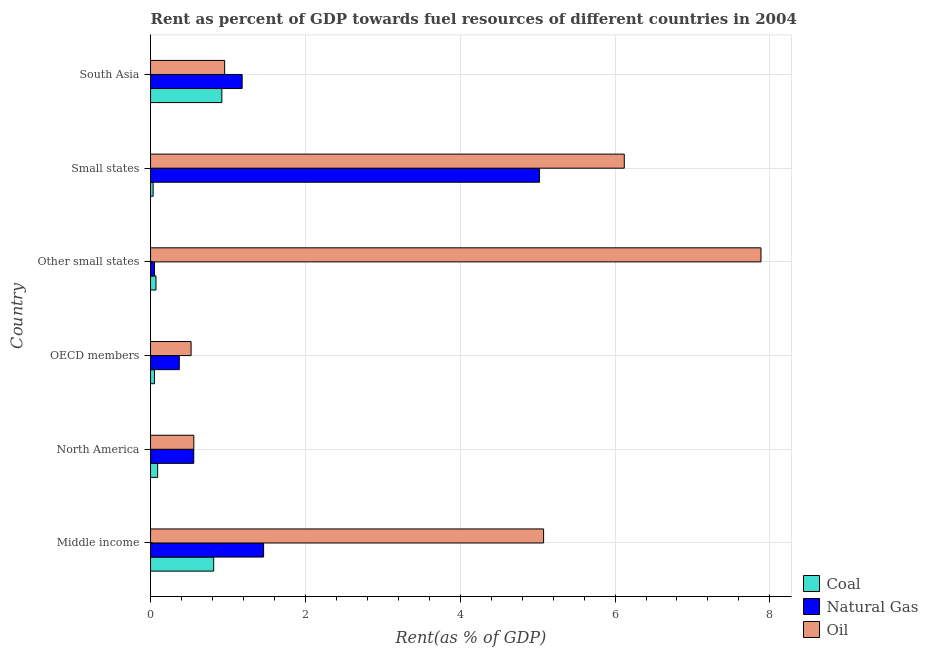How many bars are there on the 6th tick from the bottom?
Offer a very short reply. 3. What is the rent towards oil in Other small states?
Provide a succinct answer. 7.89. Across all countries, what is the maximum rent towards oil?
Offer a terse response. 7.89. Across all countries, what is the minimum rent towards coal?
Give a very brief answer. 0.03. In which country was the rent towards natural gas maximum?
Your answer should be very brief. Small states. In which country was the rent towards coal minimum?
Your response must be concise. Small states. What is the total rent towards oil in the graph?
Offer a terse response. 21.12. What is the difference between the rent towards oil in Small states and that in South Asia?
Keep it short and to the point. 5.16. What is the difference between the rent towards natural gas in South Asia and the rent towards coal in Small states?
Provide a succinct answer. 1.15. What is the average rent towards oil per country?
Provide a short and direct response. 3.52. What is the difference between the rent towards coal and rent towards natural gas in North America?
Ensure brevity in your answer.  -0.47. What is the ratio of the rent towards natural gas in Middle income to that in South Asia?
Ensure brevity in your answer.  1.23. Is the rent towards oil in Middle income less than that in North America?
Keep it short and to the point. No. What is the difference between the highest and the second highest rent towards oil?
Provide a short and direct response. 1.77. What is the difference between the highest and the lowest rent towards natural gas?
Offer a very short reply. 4.97. What does the 1st bar from the top in South Asia represents?
Provide a short and direct response. Oil. What does the 3rd bar from the bottom in Other small states represents?
Your response must be concise. Oil. Is it the case that in every country, the sum of the rent towards coal and rent towards natural gas is greater than the rent towards oil?
Give a very brief answer. No. What is the difference between two consecutive major ticks on the X-axis?
Your response must be concise. 2. Are the values on the major ticks of X-axis written in scientific E-notation?
Your answer should be very brief. No. Does the graph contain any zero values?
Make the answer very short. No. Does the graph contain grids?
Offer a terse response. Yes. Where does the legend appear in the graph?
Your answer should be compact. Bottom right. How many legend labels are there?
Your answer should be very brief. 3. What is the title of the graph?
Provide a short and direct response. Rent as percent of GDP towards fuel resources of different countries in 2004. Does "Industry" appear as one of the legend labels in the graph?
Your response must be concise. No. What is the label or title of the X-axis?
Give a very brief answer. Rent(as % of GDP). What is the Rent(as % of GDP) of Coal in Middle income?
Provide a short and direct response. 0.82. What is the Rent(as % of GDP) of Natural Gas in Middle income?
Keep it short and to the point. 1.46. What is the Rent(as % of GDP) in Oil in Middle income?
Provide a short and direct response. 5.08. What is the Rent(as % of GDP) in Coal in North America?
Your response must be concise. 0.09. What is the Rent(as % of GDP) of Natural Gas in North America?
Ensure brevity in your answer.  0.56. What is the Rent(as % of GDP) of Oil in North America?
Your answer should be compact. 0.56. What is the Rent(as % of GDP) in Coal in OECD members?
Keep it short and to the point. 0.05. What is the Rent(as % of GDP) of Natural Gas in OECD members?
Offer a terse response. 0.37. What is the Rent(as % of GDP) of Oil in OECD members?
Make the answer very short. 0.52. What is the Rent(as % of GDP) of Coal in Other small states?
Make the answer very short. 0.07. What is the Rent(as % of GDP) of Natural Gas in Other small states?
Offer a terse response. 0.05. What is the Rent(as % of GDP) in Oil in Other small states?
Give a very brief answer. 7.89. What is the Rent(as % of GDP) in Coal in Small states?
Ensure brevity in your answer.  0.03. What is the Rent(as % of GDP) of Natural Gas in Small states?
Provide a short and direct response. 5.02. What is the Rent(as % of GDP) in Oil in Small states?
Ensure brevity in your answer.  6.12. What is the Rent(as % of GDP) of Coal in South Asia?
Your answer should be very brief. 0.92. What is the Rent(as % of GDP) in Natural Gas in South Asia?
Provide a succinct answer. 1.18. What is the Rent(as % of GDP) in Oil in South Asia?
Ensure brevity in your answer.  0.96. Across all countries, what is the maximum Rent(as % of GDP) in Coal?
Provide a succinct answer. 0.92. Across all countries, what is the maximum Rent(as % of GDP) of Natural Gas?
Offer a very short reply. 5.02. Across all countries, what is the maximum Rent(as % of GDP) in Oil?
Your answer should be very brief. 7.89. Across all countries, what is the minimum Rent(as % of GDP) of Coal?
Your response must be concise. 0.03. Across all countries, what is the minimum Rent(as % of GDP) in Natural Gas?
Provide a succinct answer. 0.05. Across all countries, what is the minimum Rent(as % of GDP) in Oil?
Keep it short and to the point. 0.52. What is the total Rent(as % of GDP) in Coal in the graph?
Offer a terse response. 1.98. What is the total Rent(as % of GDP) of Natural Gas in the graph?
Offer a very short reply. 8.65. What is the total Rent(as % of GDP) of Oil in the graph?
Offer a terse response. 21.12. What is the difference between the Rent(as % of GDP) of Coal in Middle income and that in North America?
Keep it short and to the point. 0.72. What is the difference between the Rent(as % of GDP) in Natural Gas in Middle income and that in North America?
Keep it short and to the point. 0.9. What is the difference between the Rent(as % of GDP) in Oil in Middle income and that in North America?
Keep it short and to the point. 4.52. What is the difference between the Rent(as % of GDP) in Coal in Middle income and that in OECD members?
Your answer should be compact. 0.77. What is the difference between the Rent(as % of GDP) in Natural Gas in Middle income and that in OECD members?
Your answer should be very brief. 1.09. What is the difference between the Rent(as % of GDP) of Oil in Middle income and that in OECD members?
Make the answer very short. 4.55. What is the difference between the Rent(as % of GDP) of Coal in Middle income and that in Other small states?
Make the answer very short. 0.75. What is the difference between the Rent(as % of GDP) in Natural Gas in Middle income and that in Other small states?
Offer a very short reply. 1.41. What is the difference between the Rent(as % of GDP) in Oil in Middle income and that in Other small states?
Your answer should be very brief. -2.81. What is the difference between the Rent(as % of GDP) in Coal in Middle income and that in Small states?
Provide a succinct answer. 0.78. What is the difference between the Rent(as % of GDP) in Natural Gas in Middle income and that in Small states?
Give a very brief answer. -3.56. What is the difference between the Rent(as % of GDP) of Oil in Middle income and that in Small states?
Provide a short and direct response. -1.04. What is the difference between the Rent(as % of GDP) of Coal in Middle income and that in South Asia?
Offer a terse response. -0.1. What is the difference between the Rent(as % of GDP) of Natural Gas in Middle income and that in South Asia?
Your response must be concise. 0.28. What is the difference between the Rent(as % of GDP) in Oil in Middle income and that in South Asia?
Provide a succinct answer. 4.12. What is the difference between the Rent(as % of GDP) of Coal in North America and that in OECD members?
Your answer should be compact. 0.04. What is the difference between the Rent(as % of GDP) of Natural Gas in North America and that in OECD members?
Provide a short and direct response. 0.19. What is the difference between the Rent(as % of GDP) in Oil in North America and that in OECD members?
Your answer should be very brief. 0.04. What is the difference between the Rent(as % of GDP) of Coal in North America and that in Other small states?
Provide a short and direct response. 0.02. What is the difference between the Rent(as % of GDP) of Natural Gas in North America and that in Other small states?
Your answer should be compact. 0.51. What is the difference between the Rent(as % of GDP) of Oil in North America and that in Other small states?
Your answer should be compact. -7.33. What is the difference between the Rent(as % of GDP) in Coal in North America and that in Small states?
Keep it short and to the point. 0.06. What is the difference between the Rent(as % of GDP) in Natural Gas in North America and that in Small states?
Provide a succinct answer. -4.47. What is the difference between the Rent(as % of GDP) in Oil in North America and that in Small states?
Your response must be concise. -5.56. What is the difference between the Rent(as % of GDP) of Coal in North America and that in South Asia?
Your answer should be compact. -0.83. What is the difference between the Rent(as % of GDP) of Natural Gas in North America and that in South Asia?
Ensure brevity in your answer.  -0.62. What is the difference between the Rent(as % of GDP) in Oil in North America and that in South Asia?
Your answer should be very brief. -0.4. What is the difference between the Rent(as % of GDP) in Coal in OECD members and that in Other small states?
Ensure brevity in your answer.  -0.02. What is the difference between the Rent(as % of GDP) in Natural Gas in OECD members and that in Other small states?
Your response must be concise. 0.32. What is the difference between the Rent(as % of GDP) of Oil in OECD members and that in Other small states?
Ensure brevity in your answer.  -7.36. What is the difference between the Rent(as % of GDP) in Coal in OECD members and that in Small states?
Your response must be concise. 0.02. What is the difference between the Rent(as % of GDP) of Natural Gas in OECD members and that in Small states?
Ensure brevity in your answer.  -4.65. What is the difference between the Rent(as % of GDP) in Oil in OECD members and that in Small states?
Your response must be concise. -5.6. What is the difference between the Rent(as % of GDP) of Coal in OECD members and that in South Asia?
Your response must be concise. -0.87. What is the difference between the Rent(as % of GDP) in Natural Gas in OECD members and that in South Asia?
Make the answer very short. -0.81. What is the difference between the Rent(as % of GDP) in Oil in OECD members and that in South Asia?
Your answer should be very brief. -0.43. What is the difference between the Rent(as % of GDP) in Coal in Other small states and that in Small states?
Make the answer very short. 0.04. What is the difference between the Rent(as % of GDP) of Natural Gas in Other small states and that in Small states?
Keep it short and to the point. -4.97. What is the difference between the Rent(as % of GDP) of Oil in Other small states and that in Small states?
Your answer should be very brief. 1.77. What is the difference between the Rent(as % of GDP) of Coal in Other small states and that in South Asia?
Give a very brief answer. -0.85. What is the difference between the Rent(as % of GDP) of Natural Gas in Other small states and that in South Asia?
Offer a very short reply. -1.13. What is the difference between the Rent(as % of GDP) in Oil in Other small states and that in South Asia?
Offer a terse response. 6.93. What is the difference between the Rent(as % of GDP) in Coal in Small states and that in South Asia?
Ensure brevity in your answer.  -0.89. What is the difference between the Rent(as % of GDP) in Natural Gas in Small states and that in South Asia?
Offer a very short reply. 3.84. What is the difference between the Rent(as % of GDP) in Oil in Small states and that in South Asia?
Your answer should be very brief. 5.16. What is the difference between the Rent(as % of GDP) in Coal in Middle income and the Rent(as % of GDP) in Natural Gas in North America?
Provide a succinct answer. 0.26. What is the difference between the Rent(as % of GDP) in Coal in Middle income and the Rent(as % of GDP) in Oil in North America?
Your answer should be very brief. 0.26. What is the difference between the Rent(as % of GDP) in Natural Gas in Middle income and the Rent(as % of GDP) in Oil in North America?
Your answer should be compact. 0.9. What is the difference between the Rent(as % of GDP) in Coal in Middle income and the Rent(as % of GDP) in Natural Gas in OECD members?
Your answer should be very brief. 0.44. What is the difference between the Rent(as % of GDP) in Coal in Middle income and the Rent(as % of GDP) in Oil in OECD members?
Your answer should be very brief. 0.29. What is the difference between the Rent(as % of GDP) in Natural Gas in Middle income and the Rent(as % of GDP) in Oil in OECD members?
Offer a very short reply. 0.94. What is the difference between the Rent(as % of GDP) of Coal in Middle income and the Rent(as % of GDP) of Natural Gas in Other small states?
Offer a very short reply. 0.76. What is the difference between the Rent(as % of GDP) in Coal in Middle income and the Rent(as % of GDP) in Oil in Other small states?
Provide a short and direct response. -7.07. What is the difference between the Rent(as % of GDP) of Natural Gas in Middle income and the Rent(as % of GDP) of Oil in Other small states?
Ensure brevity in your answer.  -6.42. What is the difference between the Rent(as % of GDP) of Coal in Middle income and the Rent(as % of GDP) of Natural Gas in Small states?
Give a very brief answer. -4.21. What is the difference between the Rent(as % of GDP) of Coal in Middle income and the Rent(as % of GDP) of Oil in Small states?
Provide a short and direct response. -5.3. What is the difference between the Rent(as % of GDP) in Natural Gas in Middle income and the Rent(as % of GDP) in Oil in Small states?
Keep it short and to the point. -4.66. What is the difference between the Rent(as % of GDP) in Coal in Middle income and the Rent(as % of GDP) in Natural Gas in South Asia?
Offer a terse response. -0.37. What is the difference between the Rent(as % of GDP) in Coal in Middle income and the Rent(as % of GDP) in Oil in South Asia?
Your answer should be compact. -0.14. What is the difference between the Rent(as % of GDP) in Natural Gas in Middle income and the Rent(as % of GDP) in Oil in South Asia?
Your answer should be very brief. 0.5. What is the difference between the Rent(as % of GDP) in Coal in North America and the Rent(as % of GDP) in Natural Gas in OECD members?
Ensure brevity in your answer.  -0.28. What is the difference between the Rent(as % of GDP) of Coal in North America and the Rent(as % of GDP) of Oil in OECD members?
Ensure brevity in your answer.  -0.43. What is the difference between the Rent(as % of GDP) in Natural Gas in North America and the Rent(as % of GDP) in Oil in OECD members?
Ensure brevity in your answer.  0.03. What is the difference between the Rent(as % of GDP) in Coal in North America and the Rent(as % of GDP) in Natural Gas in Other small states?
Keep it short and to the point. 0.04. What is the difference between the Rent(as % of GDP) in Coal in North America and the Rent(as % of GDP) in Oil in Other small states?
Your answer should be compact. -7.79. What is the difference between the Rent(as % of GDP) in Natural Gas in North America and the Rent(as % of GDP) in Oil in Other small states?
Your response must be concise. -7.33. What is the difference between the Rent(as % of GDP) in Coal in North America and the Rent(as % of GDP) in Natural Gas in Small states?
Keep it short and to the point. -4.93. What is the difference between the Rent(as % of GDP) of Coal in North America and the Rent(as % of GDP) of Oil in Small states?
Make the answer very short. -6.03. What is the difference between the Rent(as % of GDP) in Natural Gas in North America and the Rent(as % of GDP) in Oil in Small states?
Your response must be concise. -5.56. What is the difference between the Rent(as % of GDP) in Coal in North America and the Rent(as % of GDP) in Natural Gas in South Asia?
Keep it short and to the point. -1.09. What is the difference between the Rent(as % of GDP) in Coal in North America and the Rent(as % of GDP) in Oil in South Asia?
Offer a very short reply. -0.87. What is the difference between the Rent(as % of GDP) in Natural Gas in North America and the Rent(as % of GDP) in Oil in South Asia?
Give a very brief answer. -0.4. What is the difference between the Rent(as % of GDP) of Coal in OECD members and the Rent(as % of GDP) of Natural Gas in Other small states?
Your response must be concise. -0. What is the difference between the Rent(as % of GDP) in Coal in OECD members and the Rent(as % of GDP) in Oil in Other small states?
Offer a very short reply. -7.83. What is the difference between the Rent(as % of GDP) of Natural Gas in OECD members and the Rent(as % of GDP) of Oil in Other small states?
Your answer should be compact. -7.51. What is the difference between the Rent(as % of GDP) in Coal in OECD members and the Rent(as % of GDP) in Natural Gas in Small states?
Provide a succinct answer. -4.97. What is the difference between the Rent(as % of GDP) of Coal in OECD members and the Rent(as % of GDP) of Oil in Small states?
Provide a short and direct response. -6.07. What is the difference between the Rent(as % of GDP) in Natural Gas in OECD members and the Rent(as % of GDP) in Oil in Small states?
Offer a very short reply. -5.75. What is the difference between the Rent(as % of GDP) in Coal in OECD members and the Rent(as % of GDP) in Natural Gas in South Asia?
Provide a short and direct response. -1.13. What is the difference between the Rent(as % of GDP) of Coal in OECD members and the Rent(as % of GDP) of Oil in South Asia?
Your answer should be very brief. -0.91. What is the difference between the Rent(as % of GDP) in Natural Gas in OECD members and the Rent(as % of GDP) in Oil in South Asia?
Make the answer very short. -0.59. What is the difference between the Rent(as % of GDP) of Coal in Other small states and the Rent(as % of GDP) of Natural Gas in Small states?
Make the answer very short. -4.95. What is the difference between the Rent(as % of GDP) of Coal in Other small states and the Rent(as % of GDP) of Oil in Small states?
Offer a very short reply. -6.05. What is the difference between the Rent(as % of GDP) of Natural Gas in Other small states and the Rent(as % of GDP) of Oil in Small states?
Provide a short and direct response. -6.07. What is the difference between the Rent(as % of GDP) in Coal in Other small states and the Rent(as % of GDP) in Natural Gas in South Asia?
Keep it short and to the point. -1.11. What is the difference between the Rent(as % of GDP) of Coal in Other small states and the Rent(as % of GDP) of Oil in South Asia?
Offer a very short reply. -0.89. What is the difference between the Rent(as % of GDP) of Natural Gas in Other small states and the Rent(as % of GDP) of Oil in South Asia?
Offer a very short reply. -0.91. What is the difference between the Rent(as % of GDP) of Coal in Small states and the Rent(as % of GDP) of Natural Gas in South Asia?
Provide a succinct answer. -1.15. What is the difference between the Rent(as % of GDP) in Coal in Small states and the Rent(as % of GDP) in Oil in South Asia?
Provide a short and direct response. -0.92. What is the difference between the Rent(as % of GDP) of Natural Gas in Small states and the Rent(as % of GDP) of Oil in South Asia?
Keep it short and to the point. 4.07. What is the average Rent(as % of GDP) of Coal per country?
Keep it short and to the point. 0.33. What is the average Rent(as % of GDP) of Natural Gas per country?
Your response must be concise. 1.44. What is the average Rent(as % of GDP) in Oil per country?
Keep it short and to the point. 3.52. What is the difference between the Rent(as % of GDP) of Coal and Rent(as % of GDP) of Natural Gas in Middle income?
Provide a short and direct response. -0.64. What is the difference between the Rent(as % of GDP) in Coal and Rent(as % of GDP) in Oil in Middle income?
Ensure brevity in your answer.  -4.26. What is the difference between the Rent(as % of GDP) of Natural Gas and Rent(as % of GDP) of Oil in Middle income?
Offer a terse response. -3.62. What is the difference between the Rent(as % of GDP) of Coal and Rent(as % of GDP) of Natural Gas in North America?
Your answer should be very brief. -0.47. What is the difference between the Rent(as % of GDP) in Coal and Rent(as % of GDP) in Oil in North America?
Provide a succinct answer. -0.47. What is the difference between the Rent(as % of GDP) of Natural Gas and Rent(as % of GDP) of Oil in North America?
Your response must be concise. -0. What is the difference between the Rent(as % of GDP) in Coal and Rent(as % of GDP) in Natural Gas in OECD members?
Ensure brevity in your answer.  -0.32. What is the difference between the Rent(as % of GDP) in Coal and Rent(as % of GDP) in Oil in OECD members?
Your response must be concise. -0.47. What is the difference between the Rent(as % of GDP) of Natural Gas and Rent(as % of GDP) of Oil in OECD members?
Provide a short and direct response. -0.15. What is the difference between the Rent(as % of GDP) of Coal and Rent(as % of GDP) of Natural Gas in Other small states?
Make the answer very short. 0.02. What is the difference between the Rent(as % of GDP) in Coal and Rent(as % of GDP) in Oil in Other small states?
Offer a very short reply. -7.81. What is the difference between the Rent(as % of GDP) of Natural Gas and Rent(as % of GDP) of Oil in Other small states?
Provide a short and direct response. -7.83. What is the difference between the Rent(as % of GDP) of Coal and Rent(as % of GDP) of Natural Gas in Small states?
Offer a very short reply. -4.99. What is the difference between the Rent(as % of GDP) in Coal and Rent(as % of GDP) in Oil in Small states?
Your answer should be very brief. -6.09. What is the difference between the Rent(as % of GDP) in Natural Gas and Rent(as % of GDP) in Oil in Small states?
Provide a short and direct response. -1.09. What is the difference between the Rent(as % of GDP) of Coal and Rent(as % of GDP) of Natural Gas in South Asia?
Make the answer very short. -0.26. What is the difference between the Rent(as % of GDP) of Coal and Rent(as % of GDP) of Oil in South Asia?
Offer a terse response. -0.04. What is the difference between the Rent(as % of GDP) in Natural Gas and Rent(as % of GDP) in Oil in South Asia?
Ensure brevity in your answer.  0.23. What is the ratio of the Rent(as % of GDP) in Coal in Middle income to that in North America?
Make the answer very short. 8.89. What is the ratio of the Rent(as % of GDP) in Natural Gas in Middle income to that in North America?
Your answer should be very brief. 2.62. What is the ratio of the Rent(as % of GDP) in Oil in Middle income to that in North America?
Provide a succinct answer. 9.08. What is the ratio of the Rent(as % of GDP) in Coal in Middle income to that in OECD members?
Offer a terse response. 16.21. What is the ratio of the Rent(as % of GDP) in Natural Gas in Middle income to that in OECD members?
Provide a short and direct response. 3.93. What is the ratio of the Rent(as % of GDP) in Oil in Middle income to that in OECD members?
Keep it short and to the point. 9.69. What is the ratio of the Rent(as % of GDP) in Coal in Middle income to that in Other small states?
Your answer should be compact. 11.59. What is the ratio of the Rent(as % of GDP) in Natural Gas in Middle income to that in Other small states?
Offer a very short reply. 28.4. What is the ratio of the Rent(as % of GDP) of Oil in Middle income to that in Other small states?
Offer a very short reply. 0.64. What is the ratio of the Rent(as % of GDP) of Coal in Middle income to that in Small states?
Provide a short and direct response. 24.47. What is the ratio of the Rent(as % of GDP) of Natural Gas in Middle income to that in Small states?
Your response must be concise. 0.29. What is the ratio of the Rent(as % of GDP) in Oil in Middle income to that in Small states?
Provide a short and direct response. 0.83. What is the ratio of the Rent(as % of GDP) of Coal in Middle income to that in South Asia?
Make the answer very short. 0.89. What is the ratio of the Rent(as % of GDP) of Natural Gas in Middle income to that in South Asia?
Offer a very short reply. 1.23. What is the ratio of the Rent(as % of GDP) in Oil in Middle income to that in South Asia?
Your answer should be very brief. 5.3. What is the ratio of the Rent(as % of GDP) of Coal in North America to that in OECD members?
Offer a very short reply. 1.82. What is the ratio of the Rent(as % of GDP) of Natural Gas in North America to that in OECD members?
Your response must be concise. 1.5. What is the ratio of the Rent(as % of GDP) in Oil in North America to that in OECD members?
Give a very brief answer. 1.07. What is the ratio of the Rent(as % of GDP) of Coal in North America to that in Other small states?
Your response must be concise. 1.3. What is the ratio of the Rent(as % of GDP) in Natural Gas in North America to that in Other small states?
Keep it short and to the point. 10.86. What is the ratio of the Rent(as % of GDP) in Oil in North America to that in Other small states?
Give a very brief answer. 0.07. What is the ratio of the Rent(as % of GDP) in Coal in North America to that in Small states?
Your answer should be compact. 2.75. What is the ratio of the Rent(as % of GDP) of Oil in North America to that in Small states?
Provide a short and direct response. 0.09. What is the ratio of the Rent(as % of GDP) in Coal in North America to that in South Asia?
Give a very brief answer. 0.1. What is the ratio of the Rent(as % of GDP) of Natural Gas in North America to that in South Asia?
Provide a succinct answer. 0.47. What is the ratio of the Rent(as % of GDP) of Oil in North America to that in South Asia?
Your answer should be compact. 0.58. What is the ratio of the Rent(as % of GDP) of Coal in OECD members to that in Other small states?
Offer a terse response. 0.72. What is the ratio of the Rent(as % of GDP) of Natural Gas in OECD members to that in Other small states?
Provide a short and direct response. 7.22. What is the ratio of the Rent(as % of GDP) in Oil in OECD members to that in Other small states?
Provide a short and direct response. 0.07. What is the ratio of the Rent(as % of GDP) in Coal in OECD members to that in Small states?
Offer a very short reply. 1.51. What is the ratio of the Rent(as % of GDP) in Natural Gas in OECD members to that in Small states?
Your response must be concise. 0.07. What is the ratio of the Rent(as % of GDP) of Oil in OECD members to that in Small states?
Your answer should be compact. 0.09. What is the ratio of the Rent(as % of GDP) in Coal in OECD members to that in South Asia?
Ensure brevity in your answer.  0.05. What is the ratio of the Rent(as % of GDP) in Natural Gas in OECD members to that in South Asia?
Ensure brevity in your answer.  0.31. What is the ratio of the Rent(as % of GDP) in Oil in OECD members to that in South Asia?
Your response must be concise. 0.55. What is the ratio of the Rent(as % of GDP) in Coal in Other small states to that in Small states?
Your response must be concise. 2.11. What is the ratio of the Rent(as % of GDP) of Natural Gas in Other small states to that in Small states?
Your response must be concise. 0.01. What is the ratio of the Rent(as % of GDP) of Oil in Other small states to that in Small states?
Keep it short and to the point. 1.29. What is the ratio of the Rent(as % of GDP) of Coal in Other small states to that in South Asia?
Offer a terse response. 0.08. What is the ratio of the Rent(as % of GDP) of Natural Gas in Other small states to that in South Asia?
Offer a terse response. 0.04. What is the ratio of the Rent(as % of GDP) of Oil in Other small states to that in South Asia?
Provide a short and direct response. 8.24. What is the ratio of the Rent(as % of GDP) of Coal in Small states to that in South Asia?
Offer a very short reply. 0.04. What is the ratio of the Rent(as % of GDP) of Natural Gas in Small states to that in South Asia?
Offer a terse response. 4.25. What is the ratio of the Rent(as % of GDP) of Oil in Small states to that in South Asia?
Provide a succinct answer. 6.39. What is the difference between the highest and the second highest Rent(as % of GDP) in Coal?
Give a very brief answer. 0.1. What is the difference between the highest and the second highest Rent(as % of GDP) of Natural Gas?
Make the answer very short. 3.56. What is the difference between the highest and the second highest Rent(as % of GDP) of Oil?
Your response must be concise. 1.77. What is the difference between the highest and the lowest Rent(as % of GDP) of Coal?
Your response must be concise. 0.89. What is the difference between the highest and the lowest Rent(as % of GDP) of Natural Gas?
Your response must be concise. 4.97. What is the difference between the highest and the lowest Rent(as % of GDP) in Oil?
Provide a short and direct response. 7.36. 